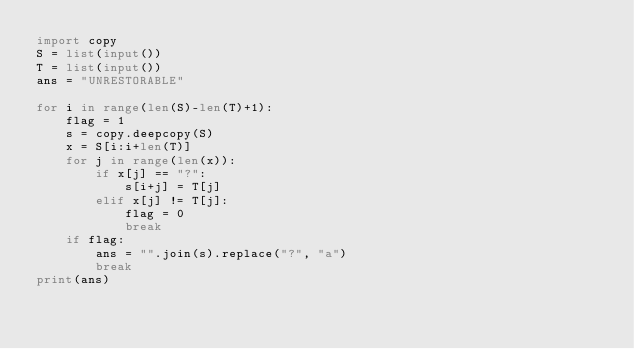<code> <loc_0><loc_0><loc_500><loc_500><_Python_>import copy
S = list(input())
T = list(input())
ans = "UNRESTORABLE"

for i in range(len(S)-len(T)+1):
    flag = 1
    s = copy.deepcopy(S)
    x = S[i:i+len(T)]
    for j in range(len(x)):
        if x[j] == "?":
            s[i+j] = T[j]
        elif x[j] != T[j]:
            flag = 0
            break
    if flag:
        ans = "".join(s).replace("?", "a")
        break
print(ans)</code> 